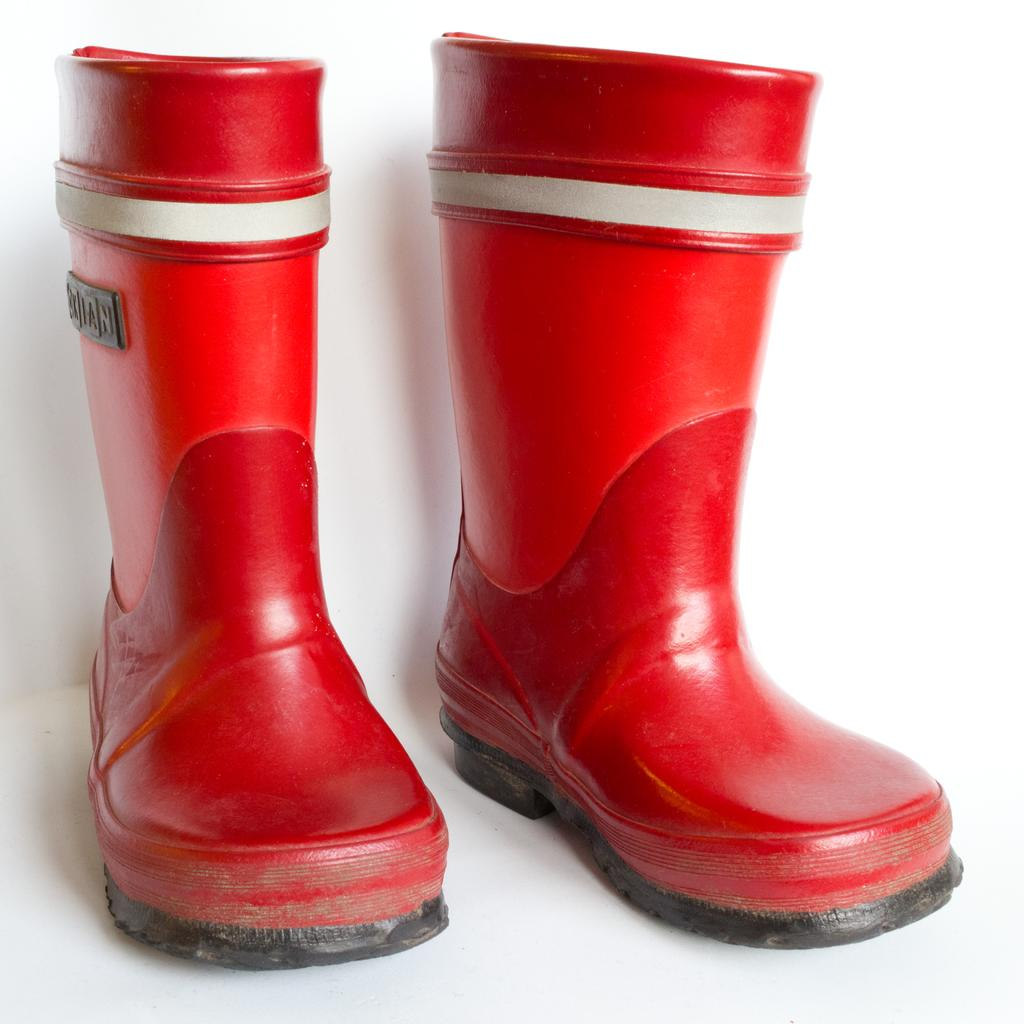What type of footwear is visible in the image? There are two red color boots in the image. What is the color of the boots? The boots are red. What is the surface on which the boots are placed? The boots are on a white surface. What type of paint is used to create the boots in the image? There is no information about the type of paint used to create the boots in the image. 